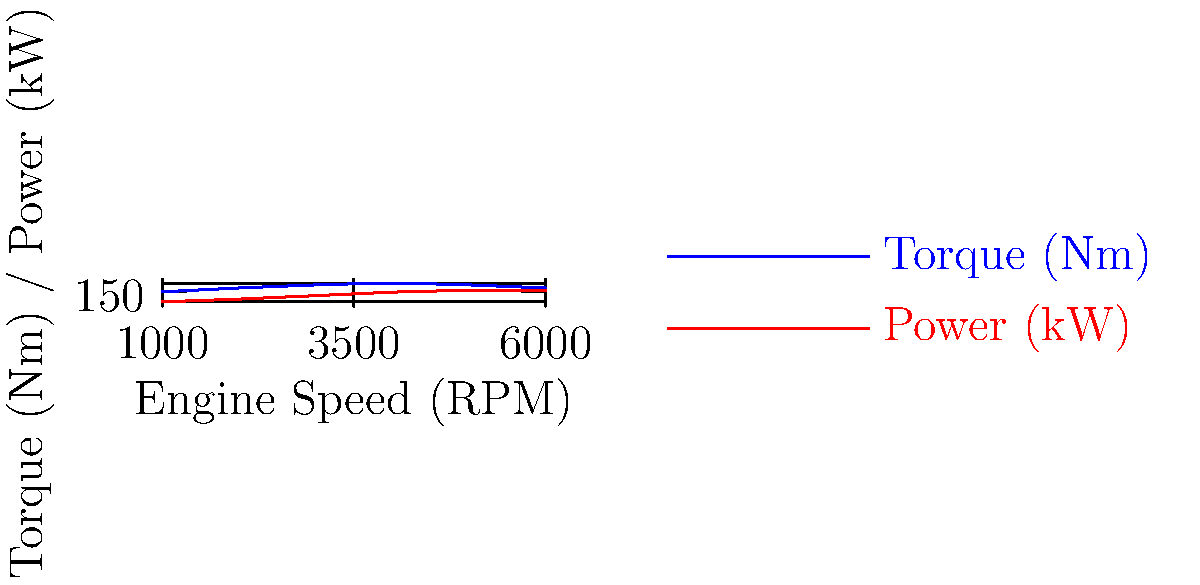You're discussing engine performance with your mechanic friend. He shows you this graph of torque and power curves for a new truck engine. At what engine speed (RPM) does this engine achieve its peak power output? To determine the engine speed at which peak power is achieved, we need to analyze the power curve (red line) on the graph. Let's break it down step-by-step:

1. Observe the power curve (red line) on the graph.
2. Follow the curve from left to right, noting how it increases.
3. Identify the highest point on the power curve.
4. This highest point represents the peak power output.
5. From the peak, draw an imaginary vertical line down to the x-axis.
6. Read the corresponding engine speed (RPM) value on the x-axis.

Looking at the graph, we can see that the power curve reaches its highest point at approximately 5000 RPM. After this point, the power begins to decrease.

It's worth noting that this peak power RPM is different from the peak torque RPM, which occurs at a lower engine speed (around 4000 RPM). This is typical for most engines, where peak torque is achieved at a lower RPM than peak power.

Understanding these curves is crucial for optimizing engine performance and fuel efficiency in trucks.
Answer: 5000 RPM 